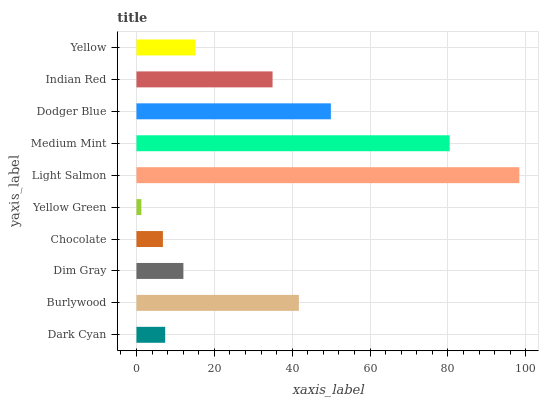Is Yellow Green the minimum?
Answer yes or no. Yes. Is Light Salmon the maximum?
Answer yes or no. Yes. Is Burlywood the minimum?
Answer yes or no. No. Is Burlywood the maximum?
Answer yes or no. No. Is Burlywood greater than Dark Cyan?
Answer yes or no. Yes. Is Dark Cyan less than Burlywood?
Answer yes or no. Yes. Is Dark Cyan greater than Burlywood?
Answer yes or no. No. Is Burlywood less than Dark Cyan?
Answer yes or no. No. Is Indian Red the high median?
Answer yes or no. Yes. Is Yellow the low median?
Answer yes or no. Yes. Is Medium Mint the high median?
Answer yes or no. No. Is Light Salmon the low median?
Answer yes or no. No. 